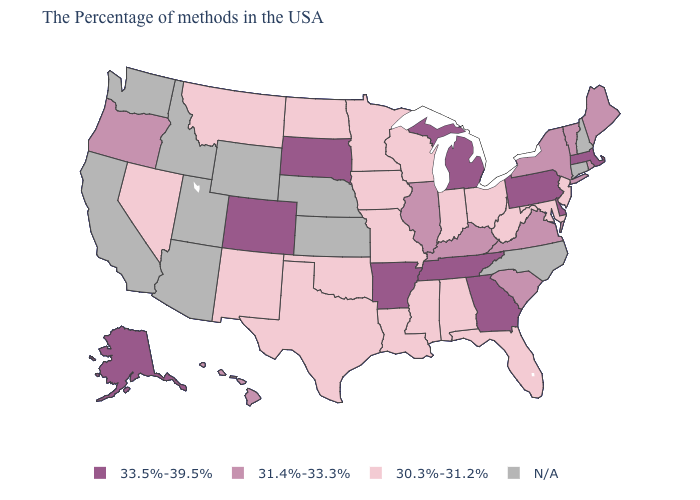Name the states that have a value in the range 33.5%-39.5%?
Write a very short answer. Massachusetts, Delaware, Pennsylvania, Georgia, Michigan, Tennessee, Arkansas, South Dakota, Colorado, Alaska. What is the value of Alabama?
Concise answer only. 30.3%-31.2%. What is the value of Indiana?
Be succinct. 30.3%-31.2%. What is the value of Alaska?
Short answer required. 33.5%-39.5%. Name the states that have a value in the range 31.4%-33.3%?
Be succinct. Maine, Rhode Island, Vermont, New York, Virginia, South Carolina, Kentucky, Illinois, Oregon, Hawaii. What is the highest value in states that border North Carolina?
Write a very short answer. 33.5%-39.5%. Which states have the highest value in the USA?
Concise answer only. Massachusetts, Delaware, Pennsylvania, Georgia, Michigan, Tennessee, Arkansas, South Dakota, Colorado, Alaska. Among the states that border South Dakota , which have the lowest value?
Keep it brief. Minnesota, Iowa, North Dakota, Montana. Name the states that have a value in the range 33.5%-39.5%?
Keep it brief. Massachusetts, Delaware, Pennsylvania, Georgia, Michigan, Tennessee, Arkansas, South Dakota, Colorado, Alaska. Which states have the highest value in the USA?
Be succinct. Massachusetts, Delaware, Pennsylvania, Georgia, Michigan, Tennessee, Arkansas, South Dakota, Colorado, Alaska. Does Tennessee have the lowest value in the South?
Give a very brief answer. No. What is the value of Delaware?
Be succinct. 33.5%-39.5%. Does the first symbol in the legend represent the smallest category?
Short answer required. No. 